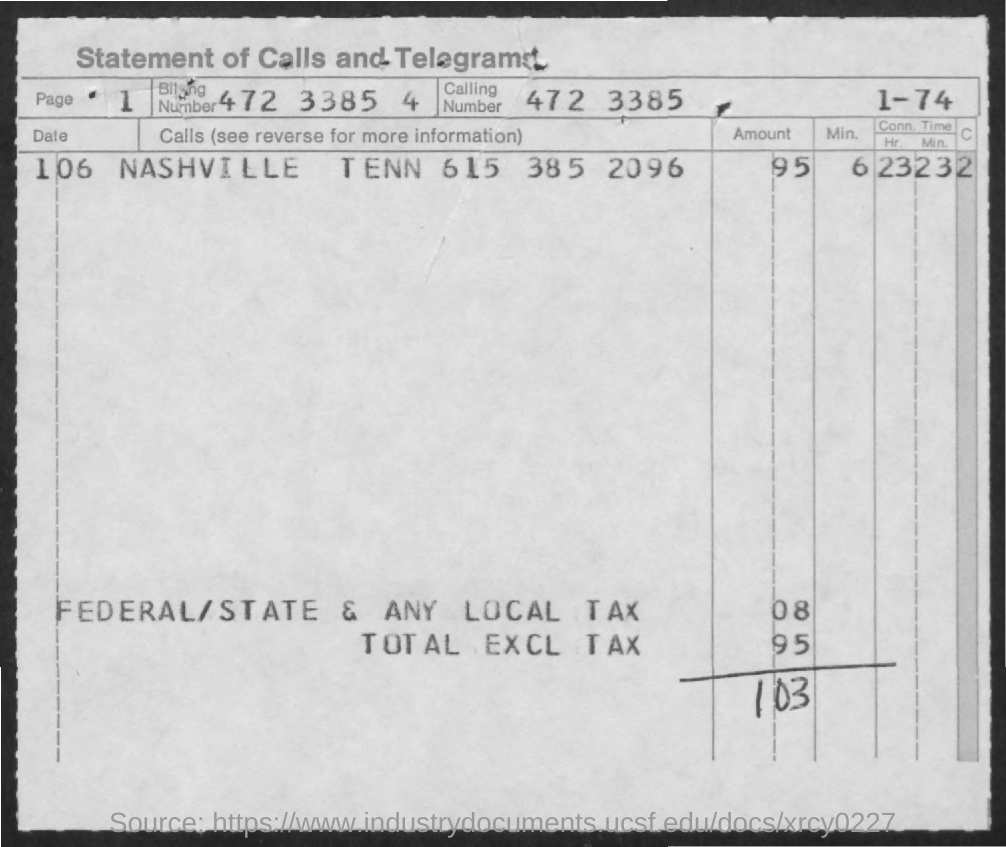What is the Page Number ?
Keep it short and to the point. 1. What is the Calling Number ?
Your answer should be very brief. 472 3385. How much Total EXCL TAX ?
Provide a short and direct response. 95. 